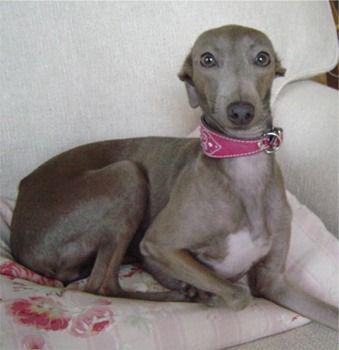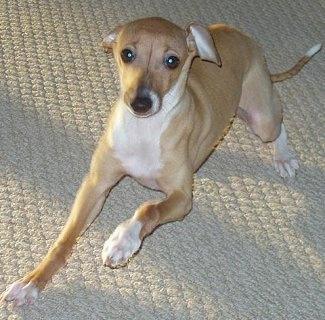The first image is the image on the left, the second image is the image on the right. For the images displayed, is the sentence "There is at least one dog laying down." factually correct? Answer yes or no. Yes. 